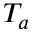Convert formula to latex. <formula><loc_0><loc_0><loc_500><loc_500>T _ { a }</formula> 